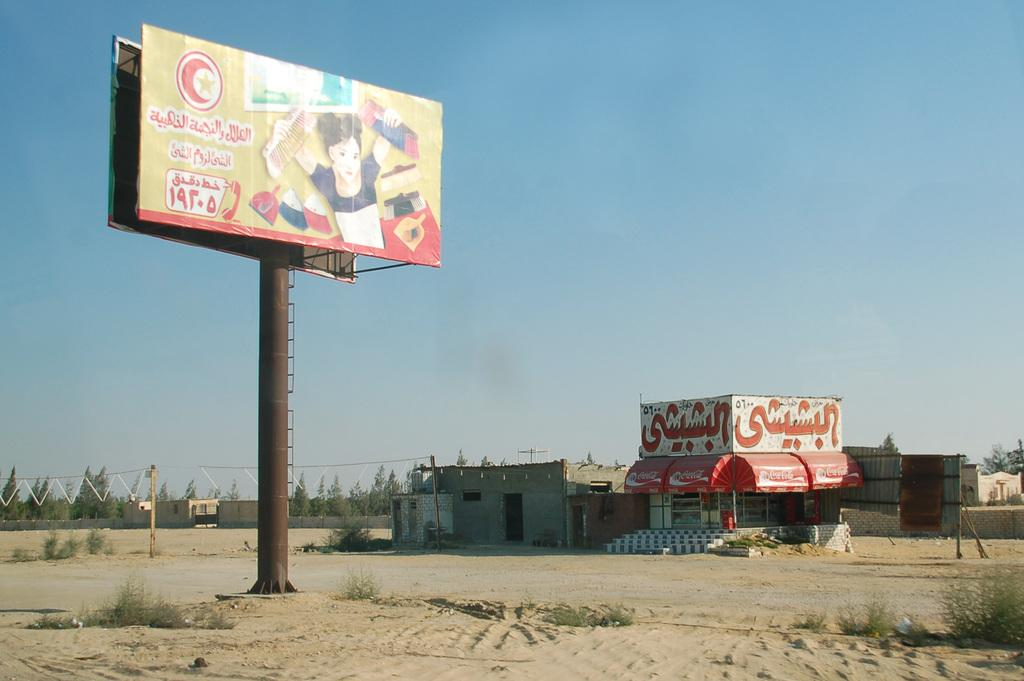What type of land is visible in the image? There is a land in the image, but no specific details about the type of land are provided. What is located near the land in the image? There is a hoarding in the image. What other elements can be seen in the image? There are plants, houses, poles, trees, and the sky visible in the image. What color is the gold in the image? There is no gold present in the image. How does the throat of the person in the image look? There is no person present in the image, so it is not possible to determine the appearance of their throat. 